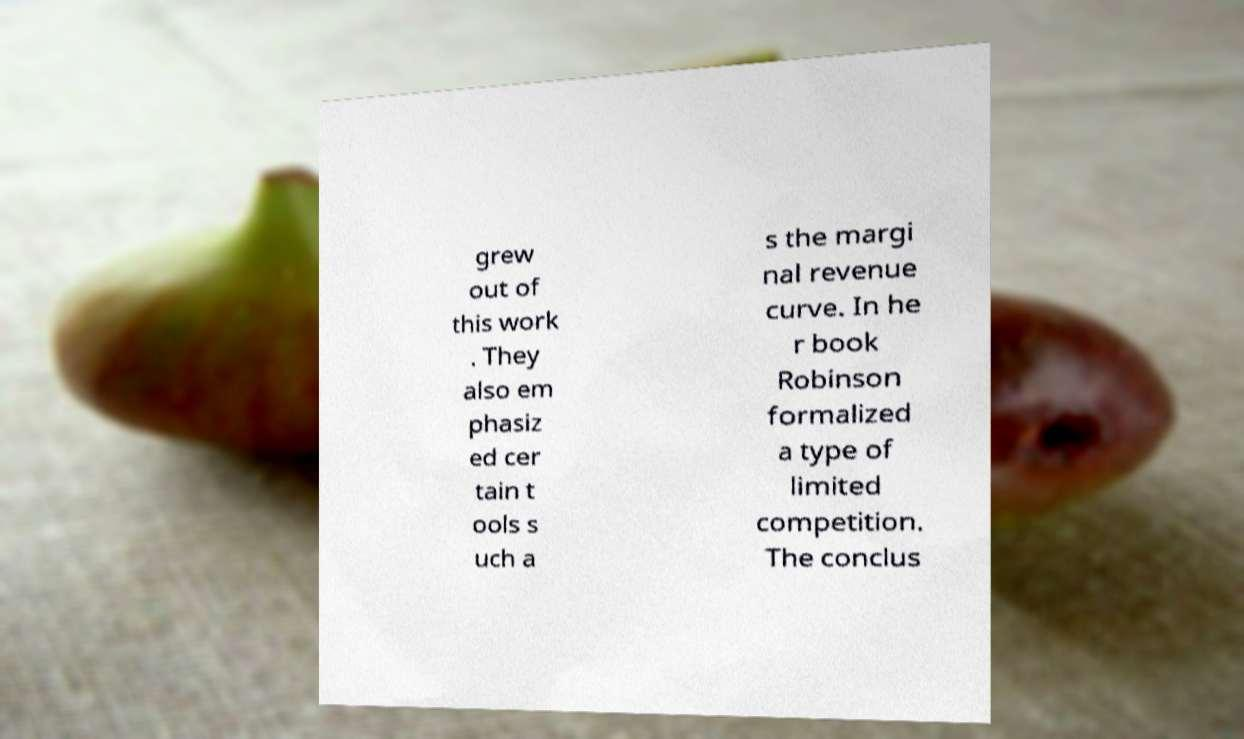Please identify and transcribe the text found in this image. grew out of this work . They also em phasiz ed cer tain t ools s uch a s the margi nal revenue curve. In he r book Robinson formalized a type of limited competition. The conclus 